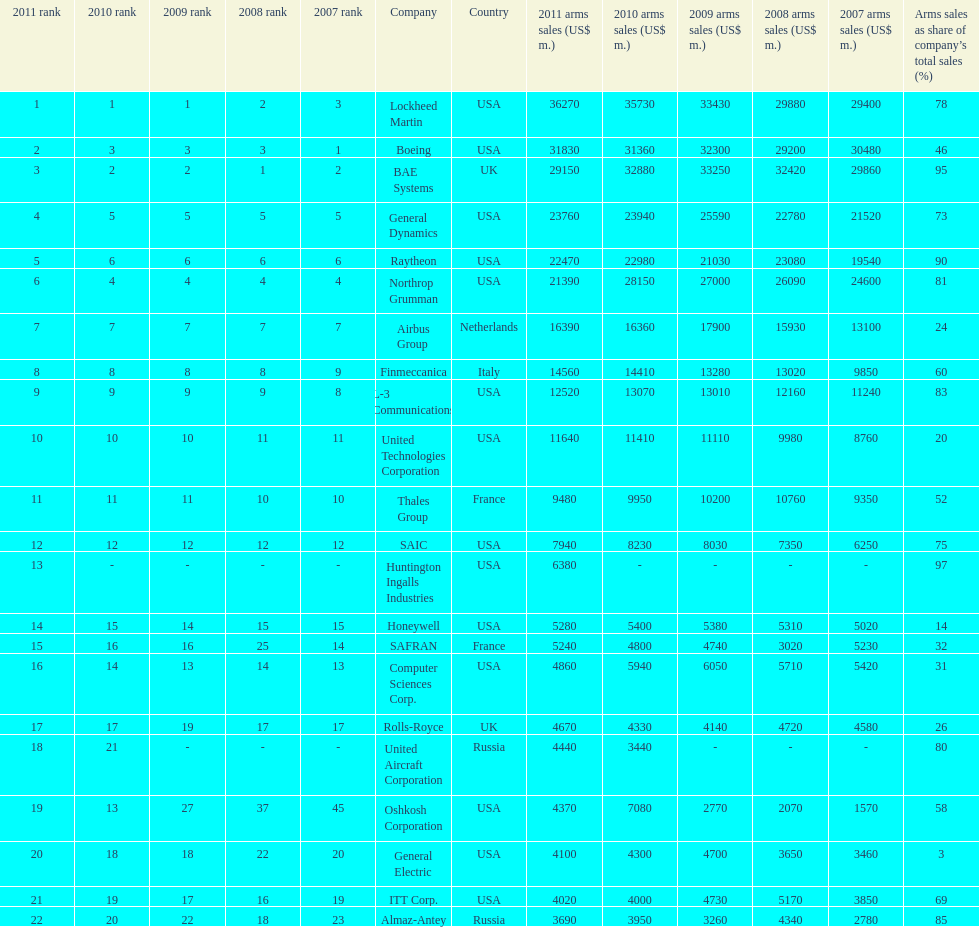What is the difference of the amount sold between boeing and general dynamics in 2007? 8960. 